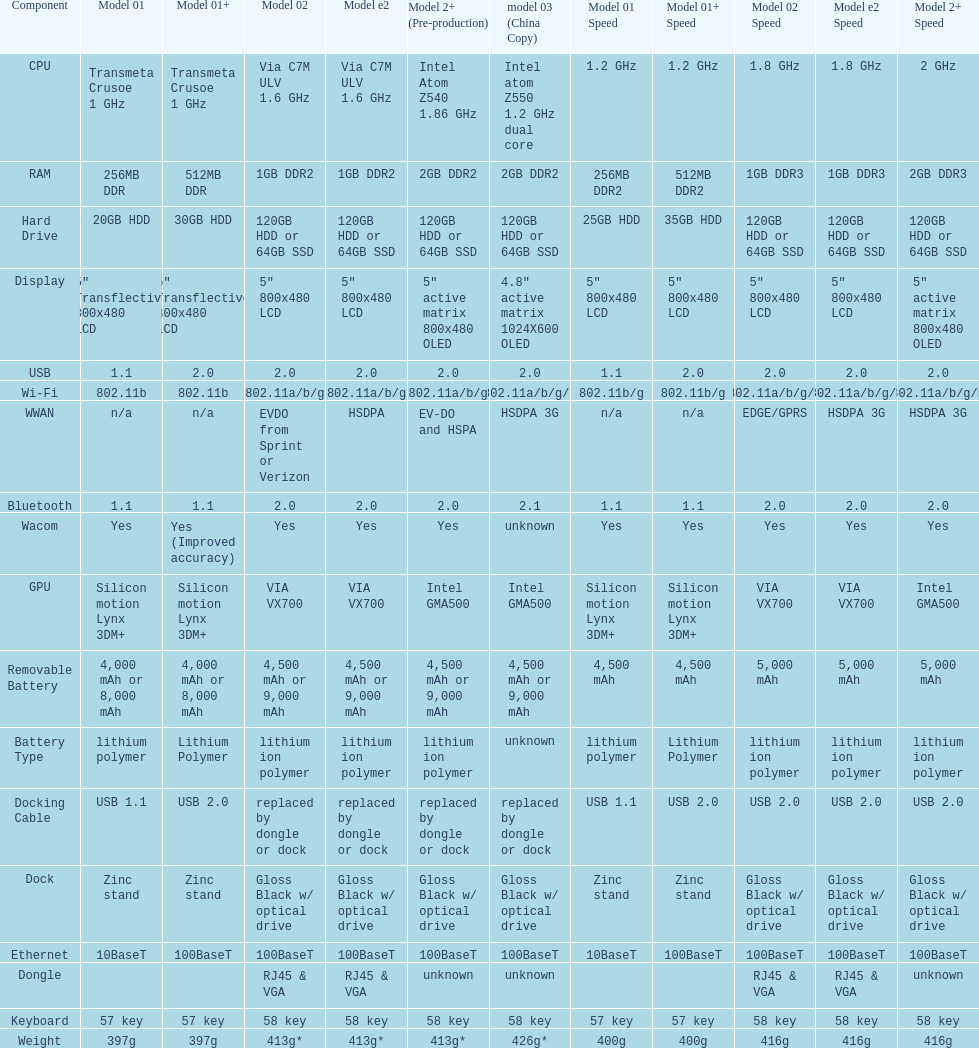What type of central processing unit is present in the model 2 and model 2e? Via C7M ULV 1.6 GHz. 